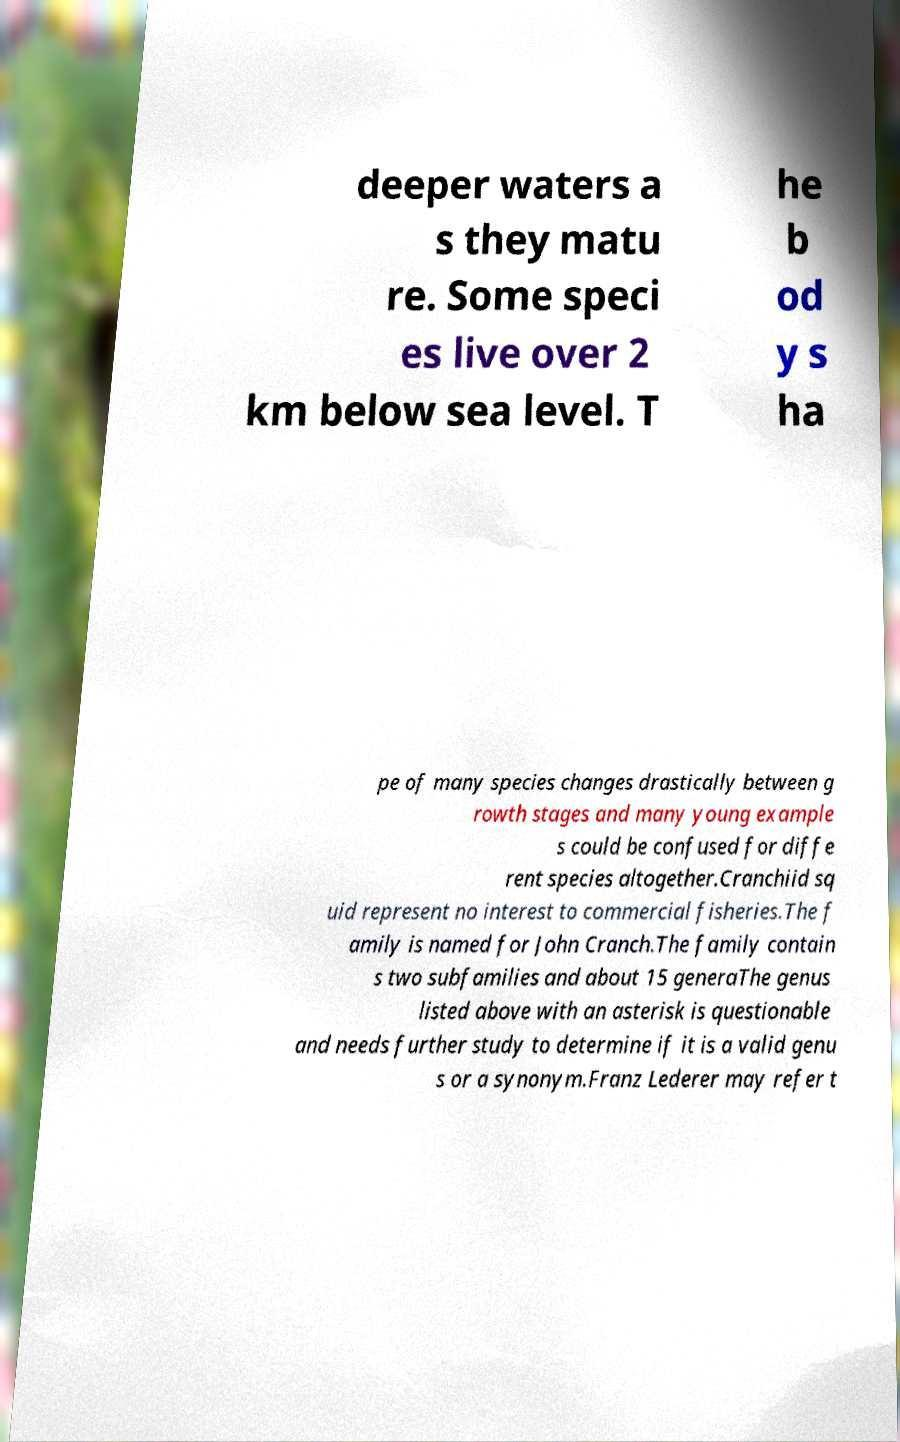Can you accurately transcribe the text from the provided image for me? deeper waters a s they matu re. Some speci es live over 2 km below sea level. T he b od y s ha pe of many species changes drastically between g rowth stages and many young example s could be confused for diffe rent species altogether.Cranchiid sq uid represent no interest to commercial fisheries.The f amily is named for John Cranch.The family contain s two subfamilies and about 15 generaThe genus listed above with an asterisk is questionable and needs further study to determine if it is a valid genu s or a synonym.Franz Lederer may refer t 